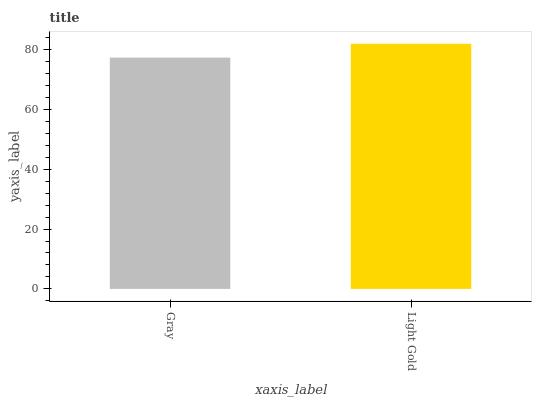Is Gray the minimum?
Answer yes or no. Yes. Is Light Gold the maximum?
Answer yes or no. Yes. Is Light Gold the minimum?
Answer yes or no. No. Is Light Gold greater than Gray?
Answer yes or no. Yes. Is Gray less than Light Gold?
Answer yes or no. Yes. Is Gray greater than Light Gold?
Answer yes or no. No. Is Light Gold less than Gray?
Answer yes or no. No. Is Light Gold the high median?
Answer yes or no. Yes. Is Gray the low median?
Answer yes or no. Yes. Is Gray the high median?
Answer yes or no. No. Is Light Gold the low median?
Answer yes or no. No. 